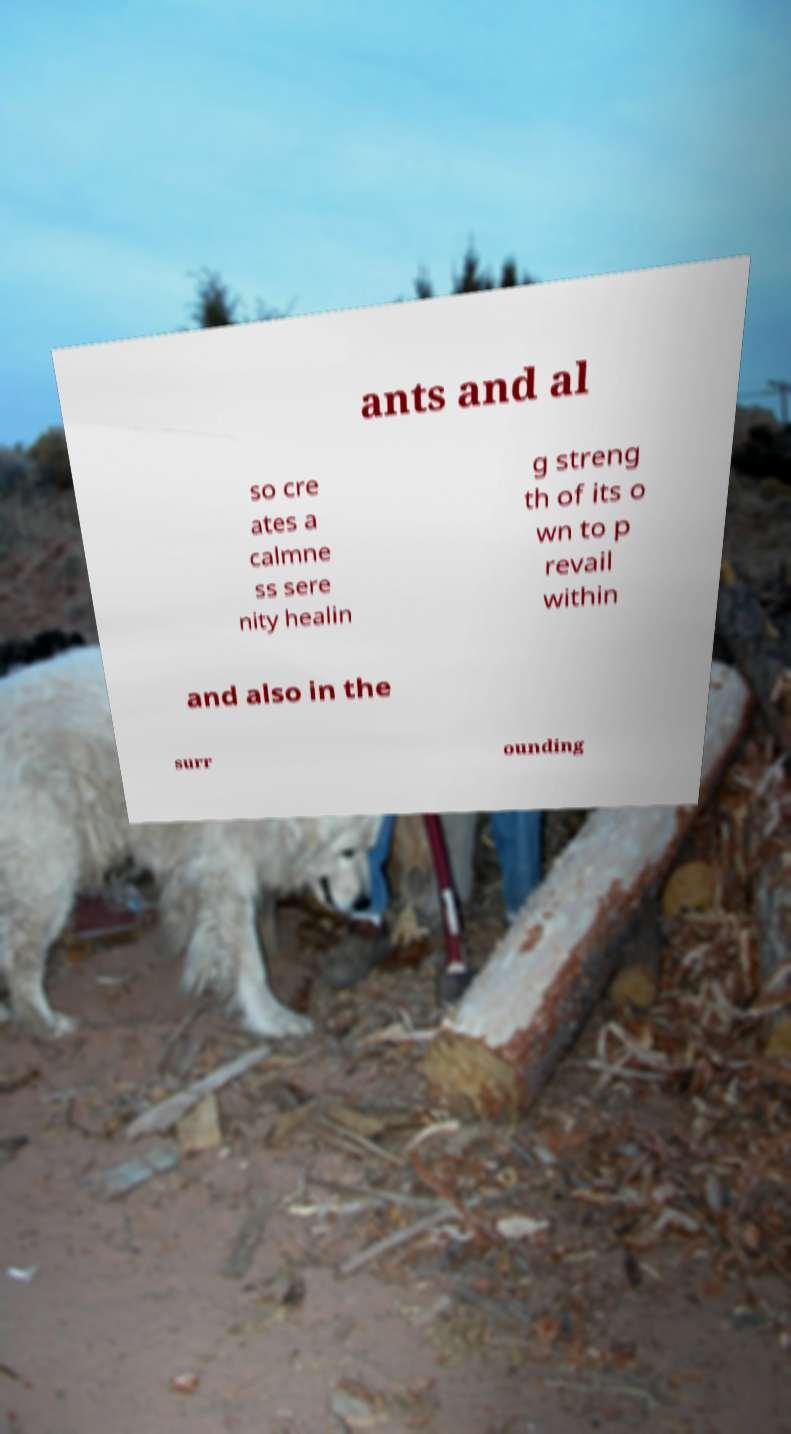I need the written content from this picture converted into text. Can you do that? ants and al so cre ates a calmne ss sere nity healin g streng th of its o wn to p revail within and also in the surr ounding 